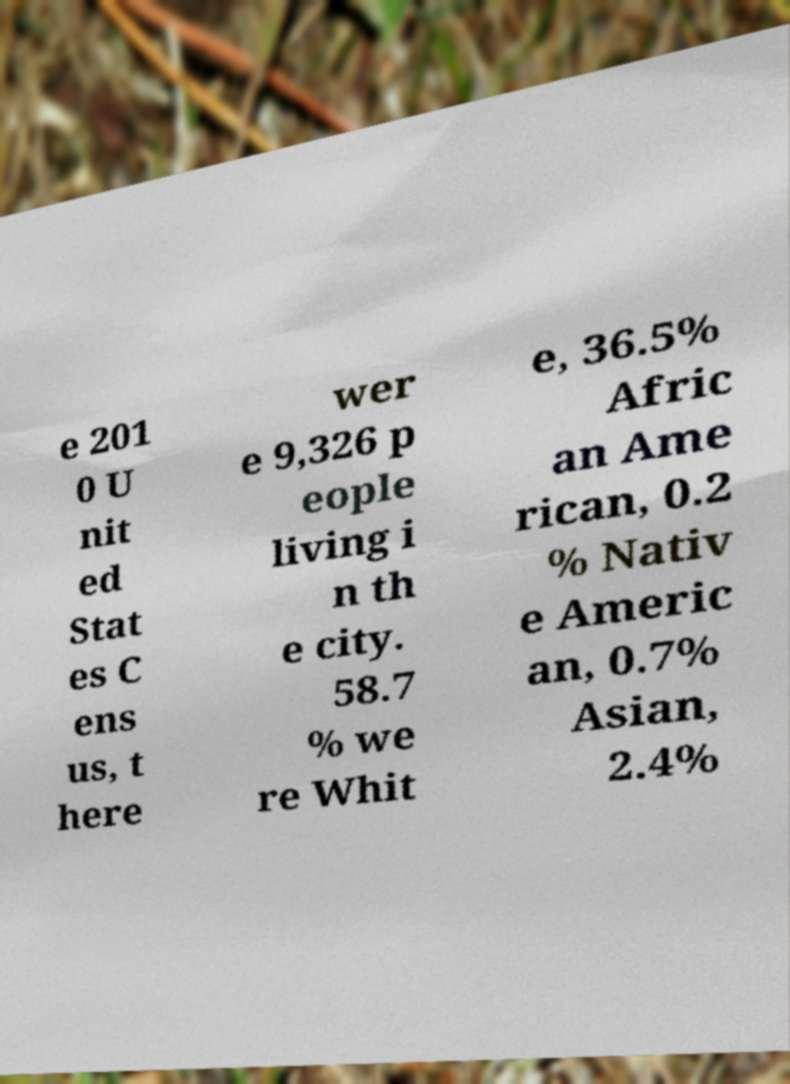Can you read and provide the text displayed in the image?This photo seems to have some interesting text. Can you extract and type it out for me? e 201 0 U nit ed Stat es C ens us, t here wer e 9,326 p eople living i n th e city. 58.7 % we re Whit e, 36.5% Afric an Ame rican, 0.2 % Nativ e Americ an, 0.7% Asian, 2.4% 